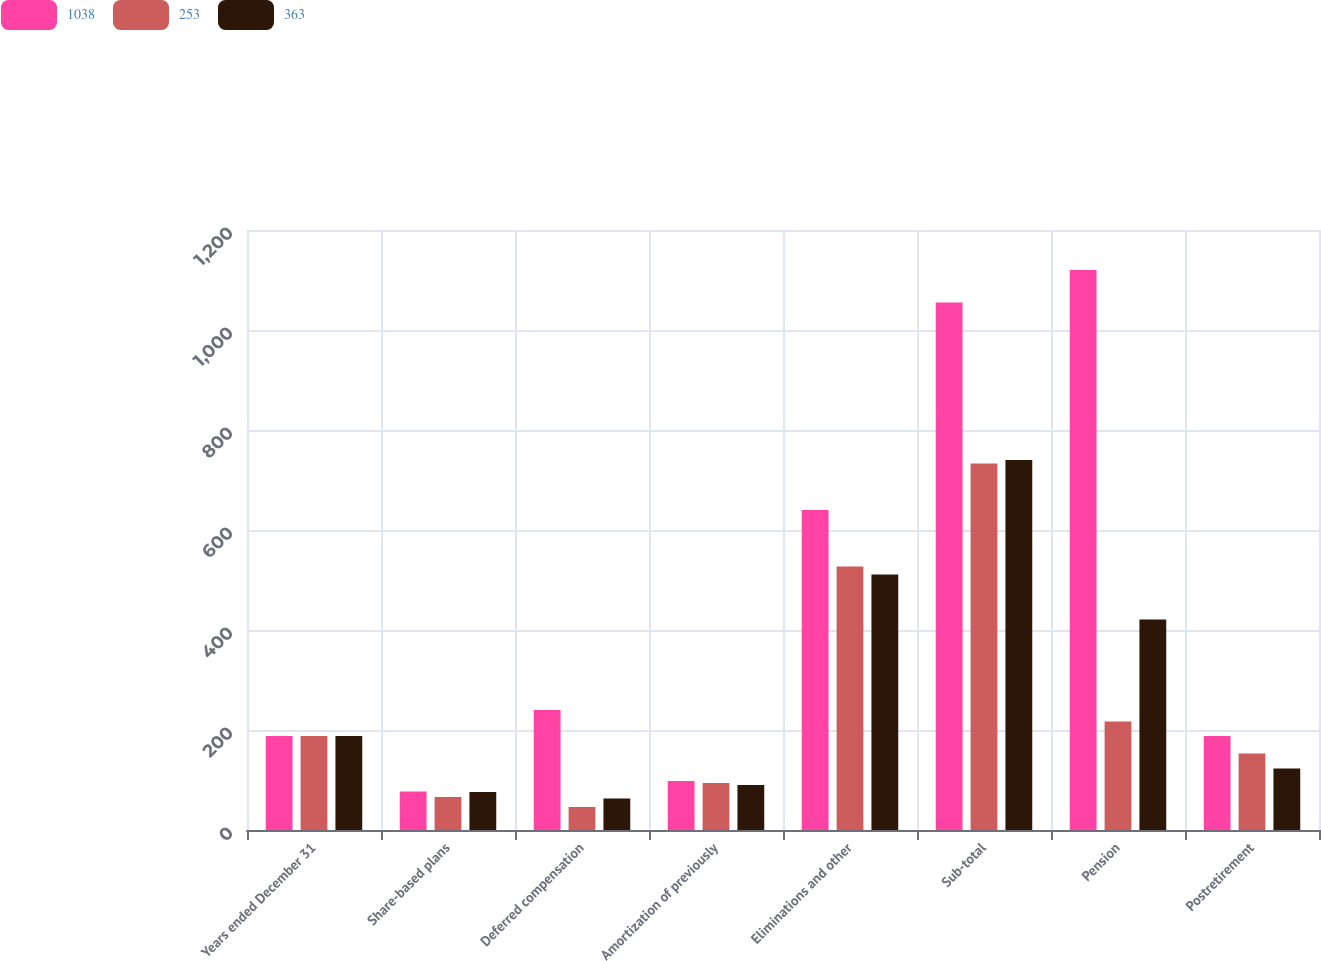Convert chart. <chart><loc_0><loc_0><loc_500><loc_500><stacked_bar_chart><ecel><fcel>Years ended December 31<fcel>Share-based plans<fcel>Deferred compensation<fcel>Amortization of previously<fcel>Eliminations and other<fcel>Sub-total<fcel>Pension<fcel>Postretirement<nl><fcel>1038<fcel>188<fcel>77<fcel>240<fcel>98<fcel>640<fcel>1055<fcel>1120<fcel>188<nl><fcel>253<fcel>188<fcel>66<fcel>46<fcel>94<fcel>527<fcel>733<fcel>217<fcel>153<nl><fcel>363<fcel>188<fcel>76<fcel>63<fcel>90<fcel>511<fcel>740<fcel>421<fcel>123<nl></chart> 